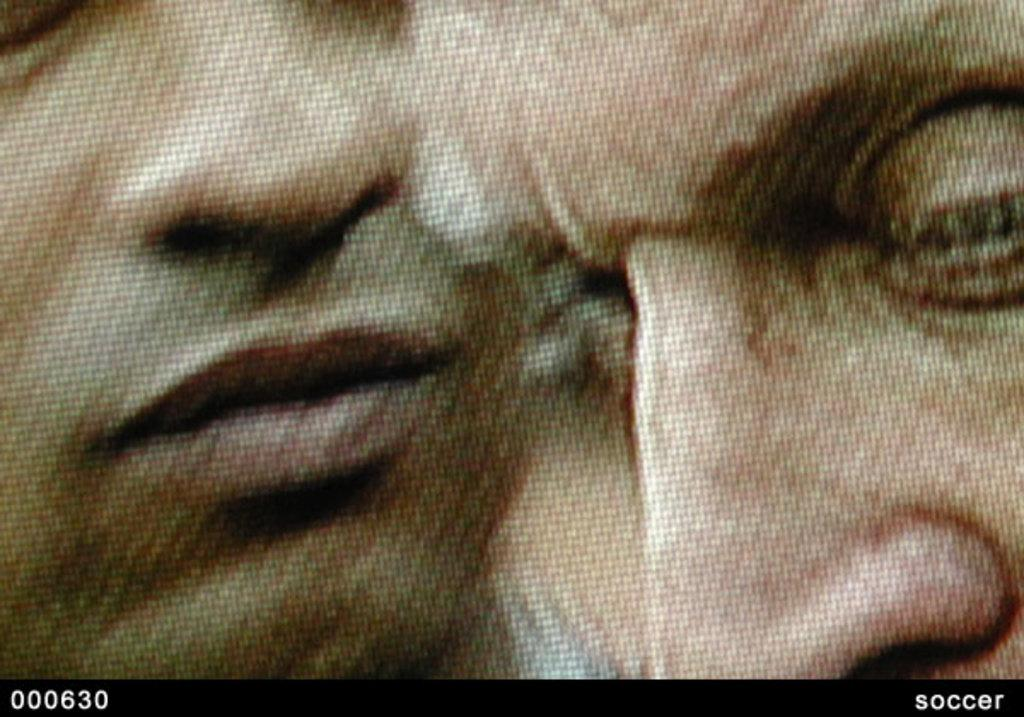What is the main subject of the image? The main subject of the image is a picture. What can be seen in the picture? The picture contains two faces. Where is the word "SOCCER" located in the image? The word "SOCCER" is present at the right side bottom of the image. What type of potato is being used as a quilt in the image? There is no potato or quilt present in the image. How many heads are visible in the image? The image contains two faces, but it does not show any additional heads. 